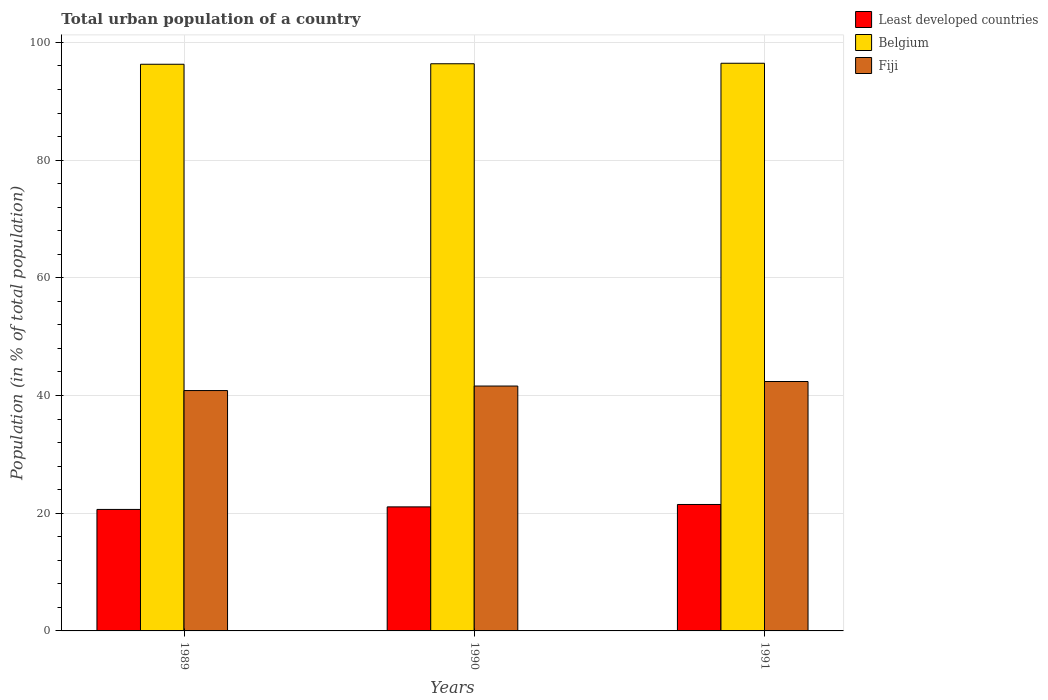How many different coloured bars are there?
Keep it short and to the point. 3. Are the number of bars per tick equal to the number of legend labels?
Provide a short and direct response. Yes. Are the number of bars on each tick of the X-axis equal?
Your answer should be very brief. Yes. How many bars are there on the 2nd tick from the left?
Give a very brief answer. 3. How many bars are there on the 3rd tick from the right?
Ensure brevity in your answer.  3. In how many cases, is the number of bars for a given year not equal to the number of legend labels?
Offer a terse response. 0. What is the urban population in Fiji in 1991?
Give a very brief answer. 42.38. Across all years, what is the maximum urban population in Belgium?
Your answer should be very brief. 96.46. Across all years, what is the minimum urban population in Least developed countries?
Ensure brevity in your answer.  20.64. In which year was the urban population in Fiji maximum?
Keep it short and to the point. 1991. What is the total urban population in Fiji in the graph?
Provide a succinct answer. 124.84. What is the difference between the urban population in Belgium in 1989 and that in 1991?
Make the answer very short. -0.17. What is the difference between the urban population in Fiji in 1989 and the urban population in Least developed countries in 1990?
Provide a succinct answer. 19.77. What is the average urban population in Belgium per year?
Offer a terse response. 96.38. In the year 1991, what is the difference between the urban population in Fiji and urban population in Belgium?
Keep it short and to the point. -54.08. In how many years, is the urban population in Belgium greater than 8 %?
Offer a terse response. 3. What is the ratio of the urban population in Least developed countries in 1989 to that in 1991?
Offer a terse response. 0.96. What is the difference between the highest and the second highest urban population in Least developed countries?
Ensure brevity in your answer.  0.41. What is the difference between the highest and the lowest urban population in Belgium?
Offer a very short reply. 0.17. What does the 1st bar from the left in 1990 represents?
Give a very brief answer. Least developed countries. What does the 3rd bar from the right in 1991 represents?
Offer a terse response. Least developed countries. Is it the case that in every year, the sum of the urban population in Fiji and urban population in Belgium is greater than the urban population in Least developed countries?
Offer a terse response. Yes. Does the graph contain any zero values?
Provide a short and direct response. No. Does the graph contain grids?
Provide a short and direct response. Yes. How are the legend labels stacked?
Offer a very short reply. Vertical. What is the title of the graph?
Your answer should be compact. Total urban population of a country. Does "Somalia" appear as one of the legend labels in the graph?
Ensure brevity in your answer.  No. What is the label or title of the X-axis?
Your answer should be compact. Years. What is the label or title of the Y-axis?
Give a very brief answer. Population (in % of total population). What is the Population (in % of total population) of Least developed countries in 1989?
Your answer should be very brief. 20.64. What is the Population (in % of total population) in Belgium in 1989?
Offer a terse response. 96.29. What is the Population (in % of total population) in Fiji in 1989?
Your answer should be very brief. 40.84. What is the Population (in % of total population) in Least developed countries in 1990?
Ensure brevity in your answer.  21.08. What is the Population (in % of total population) of Belgium in 1990?
Offer a terse response. 96.38. What is the Population (in % of total population) of Fiji in 1990?
Your answer should be compact. 41.61. What is the Population (in % of total population) in Least developed countries in 1991?
Offer a terse response. 21.49. What is the Population (in % of total population) in Belgium in 1991?
Provide a short and direct response. 96.46. What is the Population (in % of total population) in Fiji in 1991?
Your answer should be compact. 42.38. Across all years, what is the maximum Population (in % of total population) in Least developed countries?
Make the answer very short. 21.49. Across all years, what is the maximum Population (in % of total population) of Belgium?
Provide a short and direct response. 96.46. Across all years, what is the maximum Population (in % of total population) in Fiji?
Make the answer very short. 42.38. Across all years, what is the minimum Population (in % of total population) of Least developed countries?
Give a very brief answer. 20.64. Across all years, what is the minimum Population (in % of total population) of Belgium?
Your answer should be compact. 96.29. Across all years, what is the minimum Population (in % of total population) of Fiji?
Offer a very short reply. 40.84. What is the total Population (in % of total population) in Least developed countries in the graph?
Your answer should be very brief. 63.21. What is the total Population (in % of total population) in Belgium in the graph?
Offer a very short reply. 289.13. What is the total Population (in % of total population) in Fiji in the graph?
Provide a succinct answer. 124.84. What is the difference between the Population (in % of total population) in Least developed countries in 1989 and that in 1990?
Offer a very short reply. -0.43. What is the difference between the Population (in % of total population) of Belgium in 1989 and that in 1990?
Your answer should be very brief. -0.09. What is the difference between the Population (in % of total population) of Fiji in 1989 and that in 1990?
Make the answer very short. -0.77. What is the difference between the Population (in % of total population) of Least developed countries in 1989 and that in 1991?
Provide a succinct answer. -0.84. What is the difference between the Population (in % of total population) of Belgium in 1989 and that in 1991?
Offer a very short reply. -0.17. What is the difference between the Population (in % of total population) of Fiji in 1989 and that in 1991?
Your response must be concise. -1.54. What is the difference between the Population (in % of total population) of Least developed countries in 1990 and that in 1991?
Your answer should be very brief. -0.41. What is the difference between the Population (in % of total population) of Belgium in 1990 and that in 1991?
Your answer should be very brief. -0.08. What is the difference between the Population (in % of total population) of Fiji in 1990 and that in 1991?
Your response must be concise. -0.77. What is the difference between the Population (in % of total population) of Least developed countries in 1989 and the Population (in % of total population) of Belgium in 1990?
Your answer should be compact. -75.73. What is the difference between the Population (in % of total population) in Least developed countries in 1989 and the Population (in % of total population) in Fiji in 1990?
Keep it short and to the point. -20.97. What is the difference between the Population (in % of total population) in Belgium in 1989 and the Population (in % of total population) in Fiji in 1990?
Keep it short and to the point. 54.68. What is the difference between the Population (in % of total population) of Least developed countries in 1989 and the Population (in % of total population) of Belgium in 1991?
Your response must be concise. -75.82. What is the difference between the Population (in % of total population) in Least developed countries in 1989 and the Population (in % of total population) in Fiji in 1991?
Offer a very short reply. -21.74. What is the difference between the Population (in % of total population) in Belgium in 1989 and the Population (in % of total population) in Fiji in 1991?
Your answer should be very brief. 53.91. What is the difference between the Population (in % of total population) in Least developed countries in 1990 and the Population (in % of total population) in Belgium in 1991?
Your answer should be compact. -75.38. What is the difference between the Population (in % of total population) of Least developed countries in 1990 and the Population (in % of total population) of Fiji in 1991?
Make the answer very short. -21.3. What is the difference between the Population (in % of total population) of Belgium in 1990 and the Population (in % of total population) of Fiji in 1991?
Your answer should be compact. 54. What is the average Population (in % of total population) of Least developed countries per year?
Your answer should be very brief. 21.07. What is the average Population (in % of total population) in Belgium per year?
Your answer should be compact. 96.38. What is the average Population (in % of total population) of Fiji per year?
Ensure brevity in your answer.  41.61. In the year 1989, what is the difference between the Population (in % of total population) of Least developed countries and Population (in % of total population) of Belgium?
Offer a very short reply. -75.65. In the year 1989, what is the difference between the Population (in % of total population) of Least developed countries and Population (in % of total population) of Fiji?
Offer a very short reply. -20.2. In the year 1989, what is the difference between the Population (in % of total population) of Belgium and Population (in % of total population) of Fiji?
Offer a terse response. 55.45. In the year 1990, what is the difference between the Population (in % of total population) in Least developed countries and Population (in % of total population) in Belgium?
Offer a very short reply. -75.3. In the year 1990, what is the difference between the Population (in % of total population) in Least developed countries and Population (in % of total population) in Fiji?
Provide a succinct answer. -20.53. In the year 1990, what is the difference between the Population (in % of total population) in Belgium and Population (in % of total population) in Fiji?
Offer a terse response. 54.77. In the year 1991, what is the difference between the Population (in % of total population) in Least developed countries and Population (in % of total population) in Belgium?
Make the answer very short. -74.98. In the year 1991, what is the difference between the Population (in % of total population) of Least developed countries and Population (in % of total population) of Fiji?
Provide a short and direct response. -20.9. In the year 1991, what is the difference between the Population (in % of total population) of Belgium and Population (in % of total population) of Fiji?
Your answer should be very brief. 54.08. What is the ratio of the Population (in % of total population) of Least developed countries in 1989 to that in 1990?
Ensure brevity in your answer.  0.98. What is the ratio of the Population (in % of total population) of Belgium in 1989 to that in 1990?
Offer a very short reply. 1. What is the ratio of the Population (in % of total population) in Fiji in 1989 to that in 1990?
Offer a terse response. 0.98. What is the ratio of the Population (in % of total population) in Least developed countries in 1989 to that in 1991?
Offer a terse response. 0.96. What is the ratio of the Population (in % of total population) of Belgium in 1989 to that in 1991?
Keep it short and to the point. 1. What is the ratio of the Population (in % of total population) in Fiji in 1989 to that in 1991?
Your response must be concise. 0.96. What is the ratio of the Population (in % of total population) in Least developed countries in 1990 to that in 1991?
Your answer should be very brief. 0.98. What is the ratio of the Population (in % of total population) in Fiji in 1990 to that in 1991?
Provide a short and direct response. 0.98. What is the difference between the highest and the second highest Population (in % of total population) of Least developed countries?
Ensure brevity in your answer.  0.41. What is the difference between the highest and the second highest Population (in % of total population) of Belgium?
Offer a very short reply. 0.08. What is the difference between the highest and the second highest Population (in % of total population) in Fiji?
Offer a very short reply. 0.77. What is the difference between the highest and the lowest Population (in % of total population) in Least developed countries?
Provide a short and direct response. 0.84. What is the difference between the highest and the lowest Population (in % of total population) of Belgium?
Provide a short and direct response. 0.17. What is the difference between the highest and the lowest Population (in % of total population) of Fiji?
Make the answer very short. 1.54. 